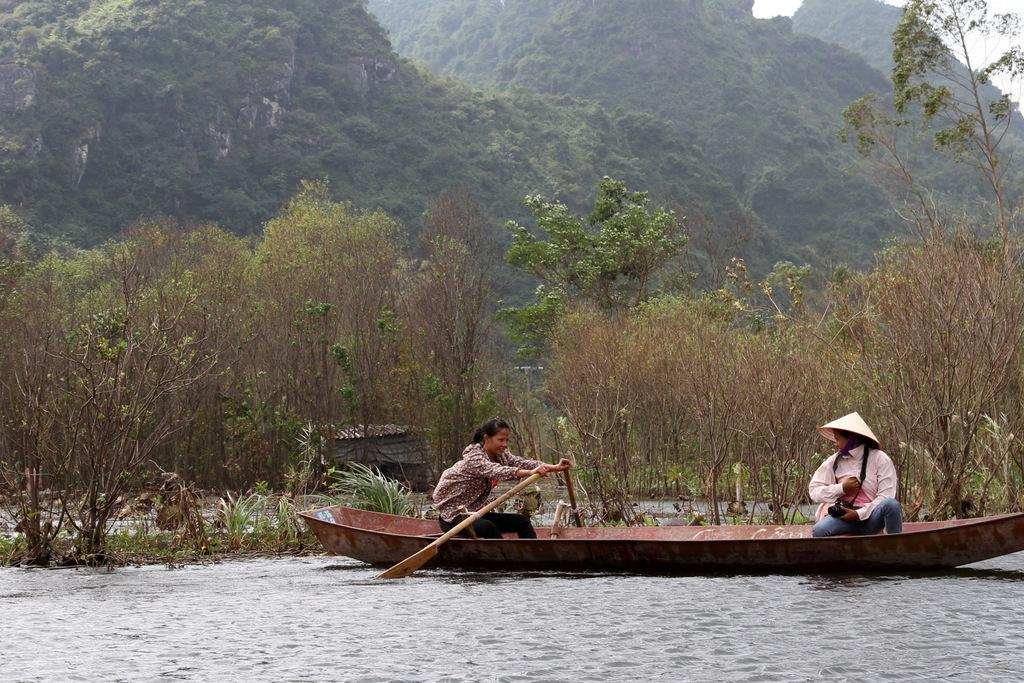What is the main subject of the image? The main subject of the image is a boat. Where is the boat located? The boat is on a river. Who is in the boat? There are two women sitting in the boat. What can be seen in the background of the image? There are trees and mountains in the background of the image. What type of hair product is being used by the women in the boat? There is no indication in the image that the women are using any hair products. 